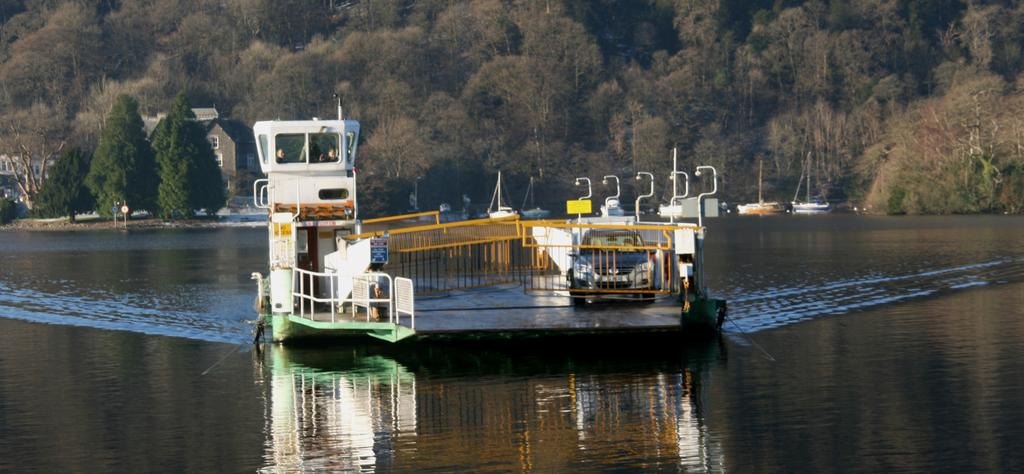What is the main subject of the image? The main subject of the image is a ship on a water body. What else can be seen on the ship? There is a car and a barricade on the ship. What is visible in the background of the image? There are trees, other ships, and buildings in the background of the image. What type of chickens can be seen roaming around on the ship? There are no chickens present in the image; the focus is on the ship, car, and barricade. 